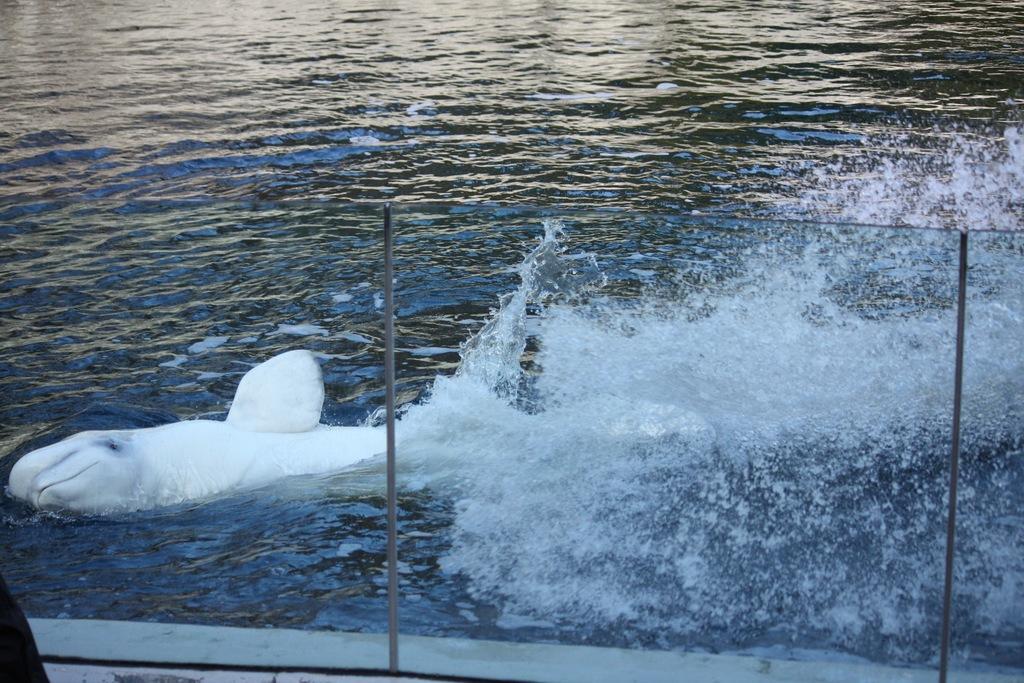How would you summarize this image in a sentence or two? In front of the image there is a glass fence with metal rods, on the other side of the fence there is a shark in the water. 